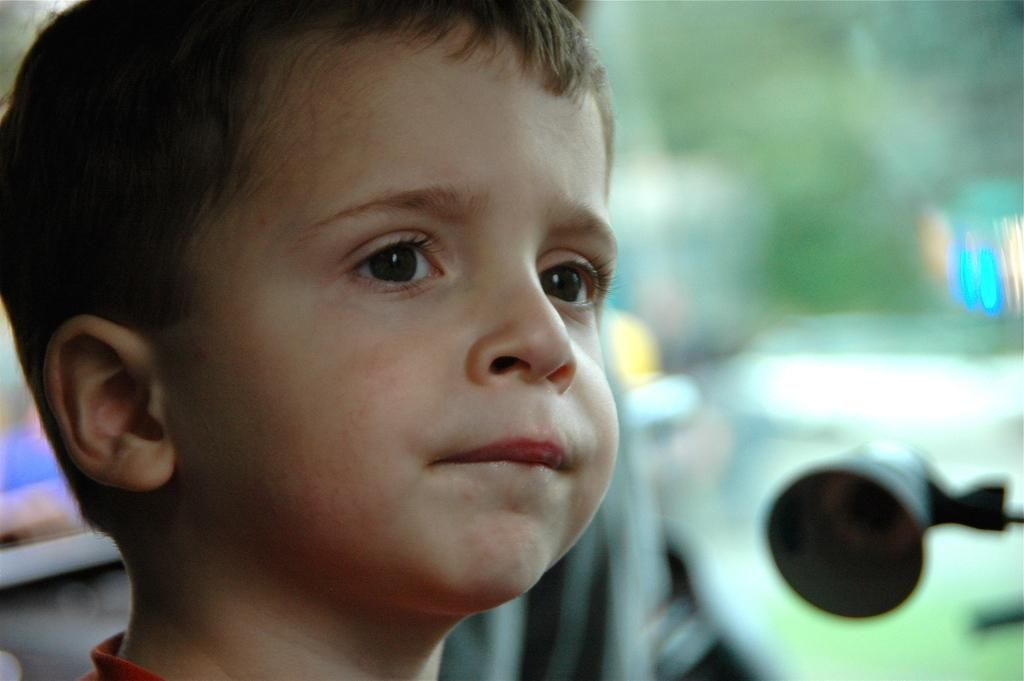What is the main subject of the picture? The main subject of the picture is a boy's face. What facial features can be seen on the boy's face? The boy's face has eyes, ears, nose, and mouth. Are there any objects placed beside the boy in the picture? Yes, there are objects placed beside the boy, but their visibility is unclear. What type of van can be seen in the background of the image? There is no van present in the image; it features a boy's face with unclear objects beside him. How does the boy's face contribute to the harmony of the image? The boy's face is the main subject of the image, and its presence does not necessarily contribute to the harmony of the image, as harmony is a subjective concept. 